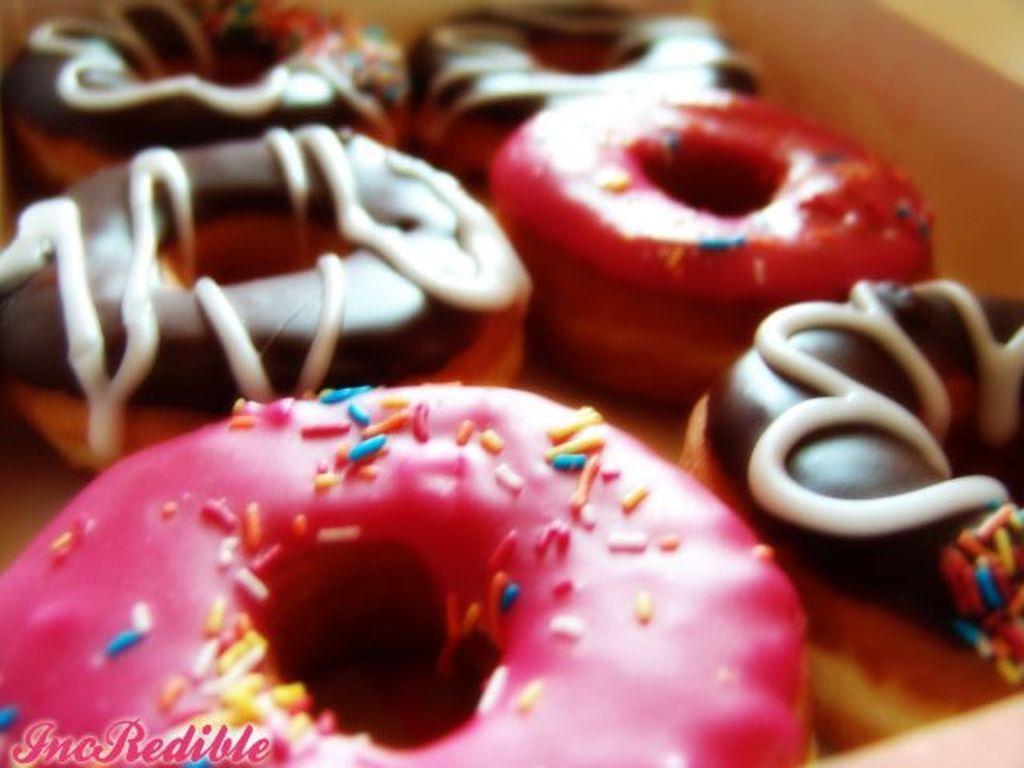What type of food is present in the image? There are doughnuts in the image. Can you describe the appearance of the doughnuts? The doughnuts have different colors. Where is the text located in the image? The text is at the left bottom of the image. Can you tell me how many lakes are visible in the image? There are no lakes present in the image; it features doughnuts and text. What type of guide is shown assisting people in the image? There is no guide present in the image; it only contains doughnuts, text, and their respective colors. 